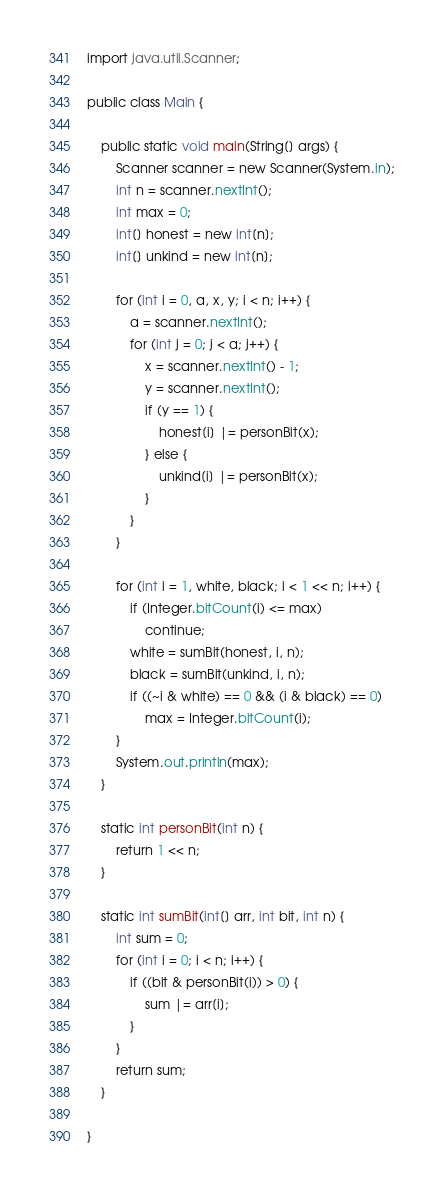Convert code to text. <code><loc_0><loc_0><loc_500><loc_500><_Java_>import java.util.Scanner;

public class Main {

	public static void main(String[] args) {
		Scanner scanner = new Scanner(System.in);
		int n = scanner.nextInt();
		int max = 0;
		int[] honest = new int[n];
		int[] unkind = new int[n];

		for (int i = 0, a, x, y; i < n; i++) {
			a = scanner.nextInt();
			for (int j = 0; j < a; j++) {
				x = scanner.nextInt() - 1;
				y = scanner.nextInt();
				if (y == 1) {
					honest[i] |= personBit(x);
				} else {
					unkind[i] |= personBit(x);
				}
			}
		}

		for (int i = 1, white, black; i < 1 << n; i++) {
			if (Integer.bitCount(i) <= max)
				continue;
			white = sumBit(honest, i, n);
			black = sumBit(unkind, i, n);
			if ((~i & white) == 0 && (i & black) == 0)
				max = Integer.bitCount(i);
		}
		System.out.println(max);
	}

	static int personBit(int n) {
		return 1 << n;
	}

	static int sumBit(int[] arr, int bit, int n) {
		int sum = 0;
		for (int i = 0; i < n; i++) {
			if ((bit & personBit(i)) > 0) {
				sum |= arr[i];
			}
		}
		return sum;
	}

}
</code> 